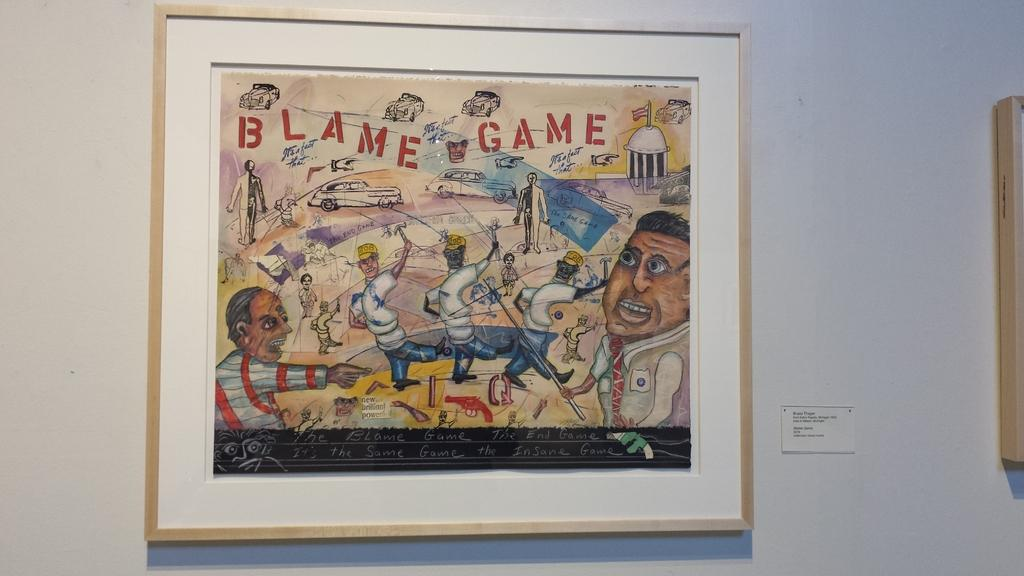Provide a one-sentence caption for the provided image. a framed colored cartoon drawing of blame game. 